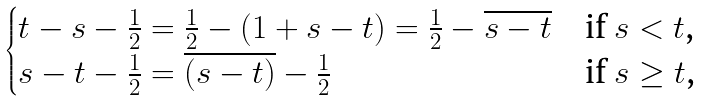Convert formula to latex. <formula><loc_0><loc_0><loc_500><loc_500>\begin{cases} t - s - \frac { 1 } { 2 } = \frac { 1 } { 2 } - ( 1 + s - t ) = \frac { 1 } { 2 } - \overline { s - t } & \text {if $s< t$,} \\ s - t - \frac { 1 } { 2 } = \overline { ( s - t ) } - \frac { 1 } { 2 } & \text {if $s\geq t$,} \end{cases}</formula> 